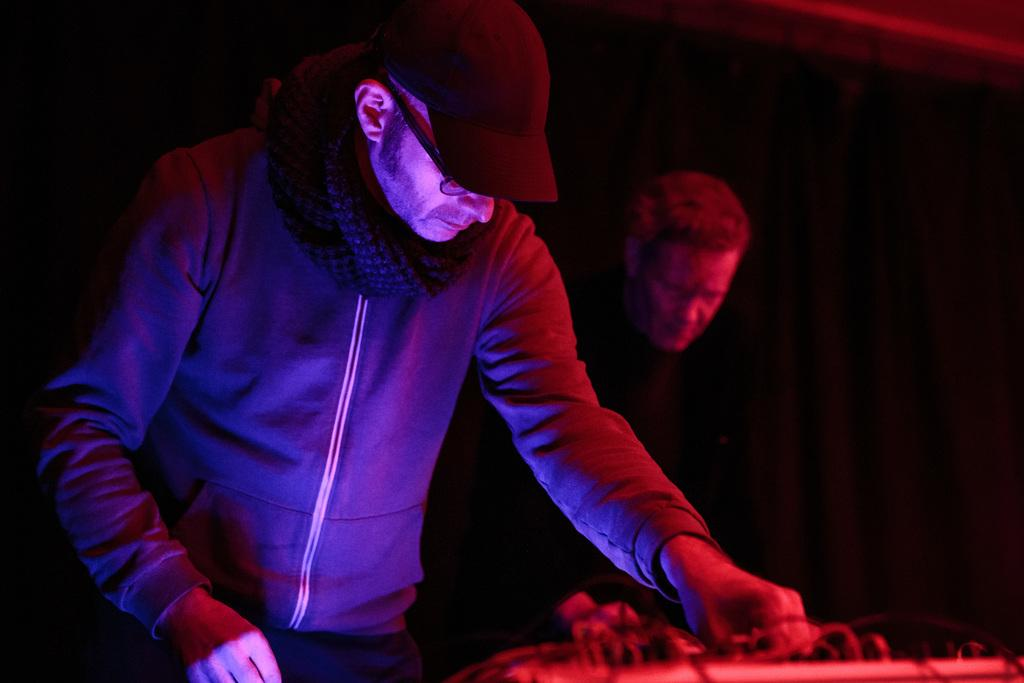How many people are in the image? There are two persons in the image. What is one of the persons doing in the image? One of the persons is standing in front of an electronic device. What can be observed about the background of the image? The background of the image is dark. What type of tax is being discussed by the persons in the image? There is no indication in the image that the persons are discussing any type of tax. 